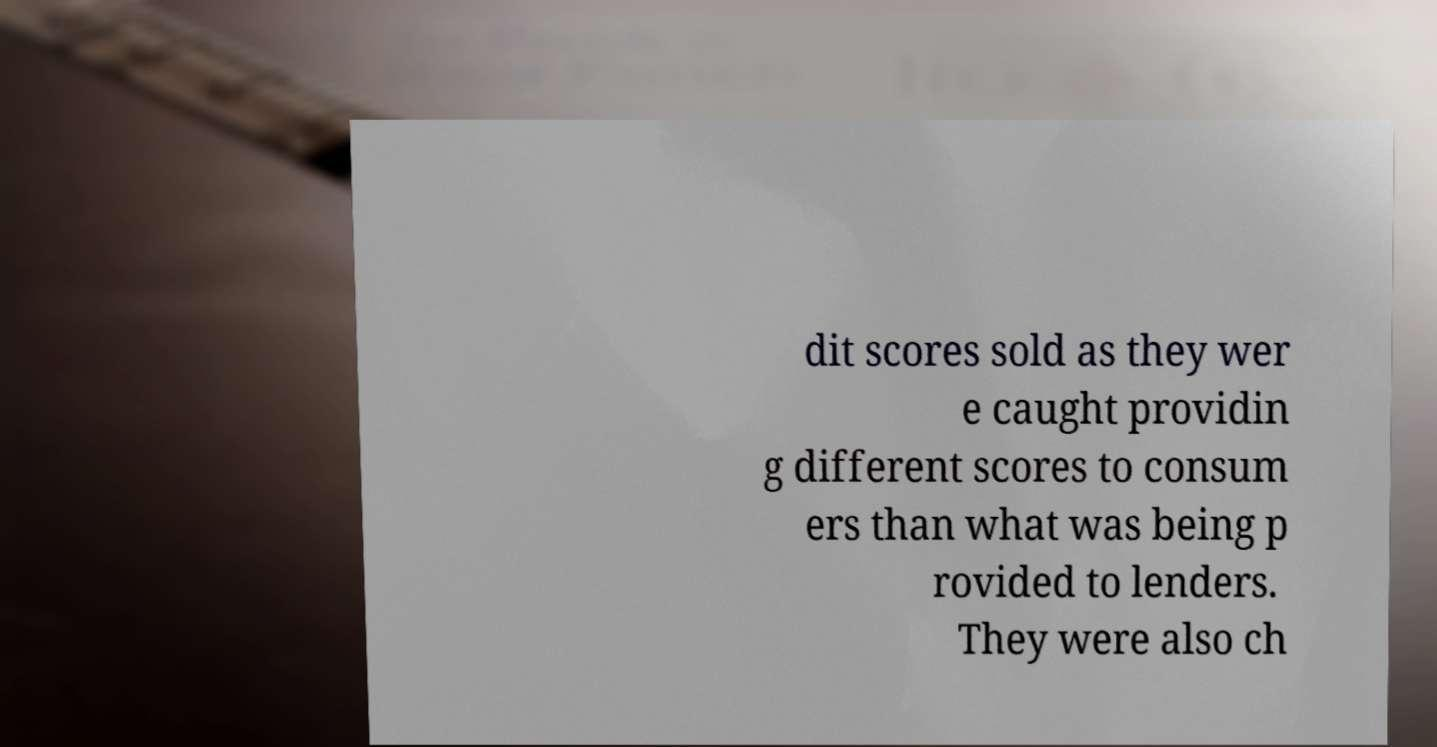What messages or text are displayed in this image? I need them in a readable, typed format. dit scores sold as they wer e caught providin g different scores to consum ers than what was being p rovided to lenders. They were also ch 